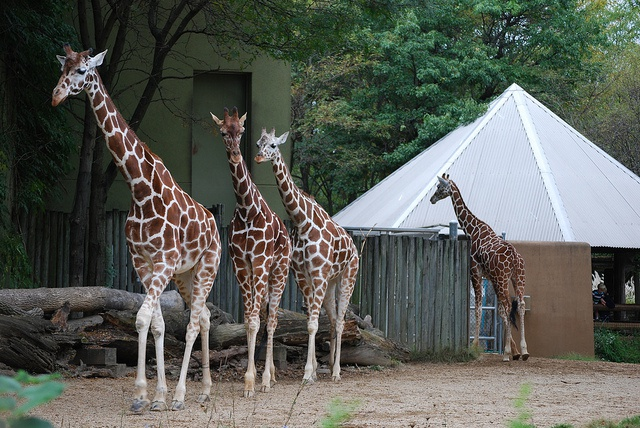Describe the objects in this image and their specific colors. I can see giraffe in black, darkgray, gray, and maroon tones, giraffe in black, maroon, darkgray, and gray tones, giraffe in black, darkgray, gray, and lightgray tones, giraffe in black, gray, maroon, and darkgray tones, and people in black, gray, and navy tones in this image. 